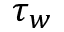<formula> <loc_0><loc_0><loc_500><loc_500>\tau _ { w }</formula> 